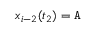Convert formula to latex. <formula><loc_0><loc_0><loc_500><loc_500>x _ { i - 2 } ( t _ { 2 } ) = A</formula> 